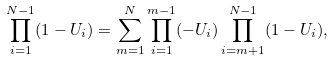Convert formula to latex. <formula><loc_0><loc_0><loc_500><loc_500>\prod _ { i = 1 } ^ { N - 1 } ( 1 - U _ { i } ) = \sum _ { m = 1 } ^ { N } \prod _ { i = 1 } ^ { m - 1 } ( - U _ { i } ) \prod _ { i = m + 1 } ^ { N - 1 } ( 1 - U _ { i } ) ,</formula> 